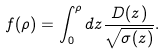Convert formula to latex. <formula><loc_0><loc_0><loc_500><loc_500>f ( \rho ) = \int _ { 0 } ^ { \rho } d z \frac { D ( z ) } { \sqrt { \sigma ( z ) } } .</formula> 